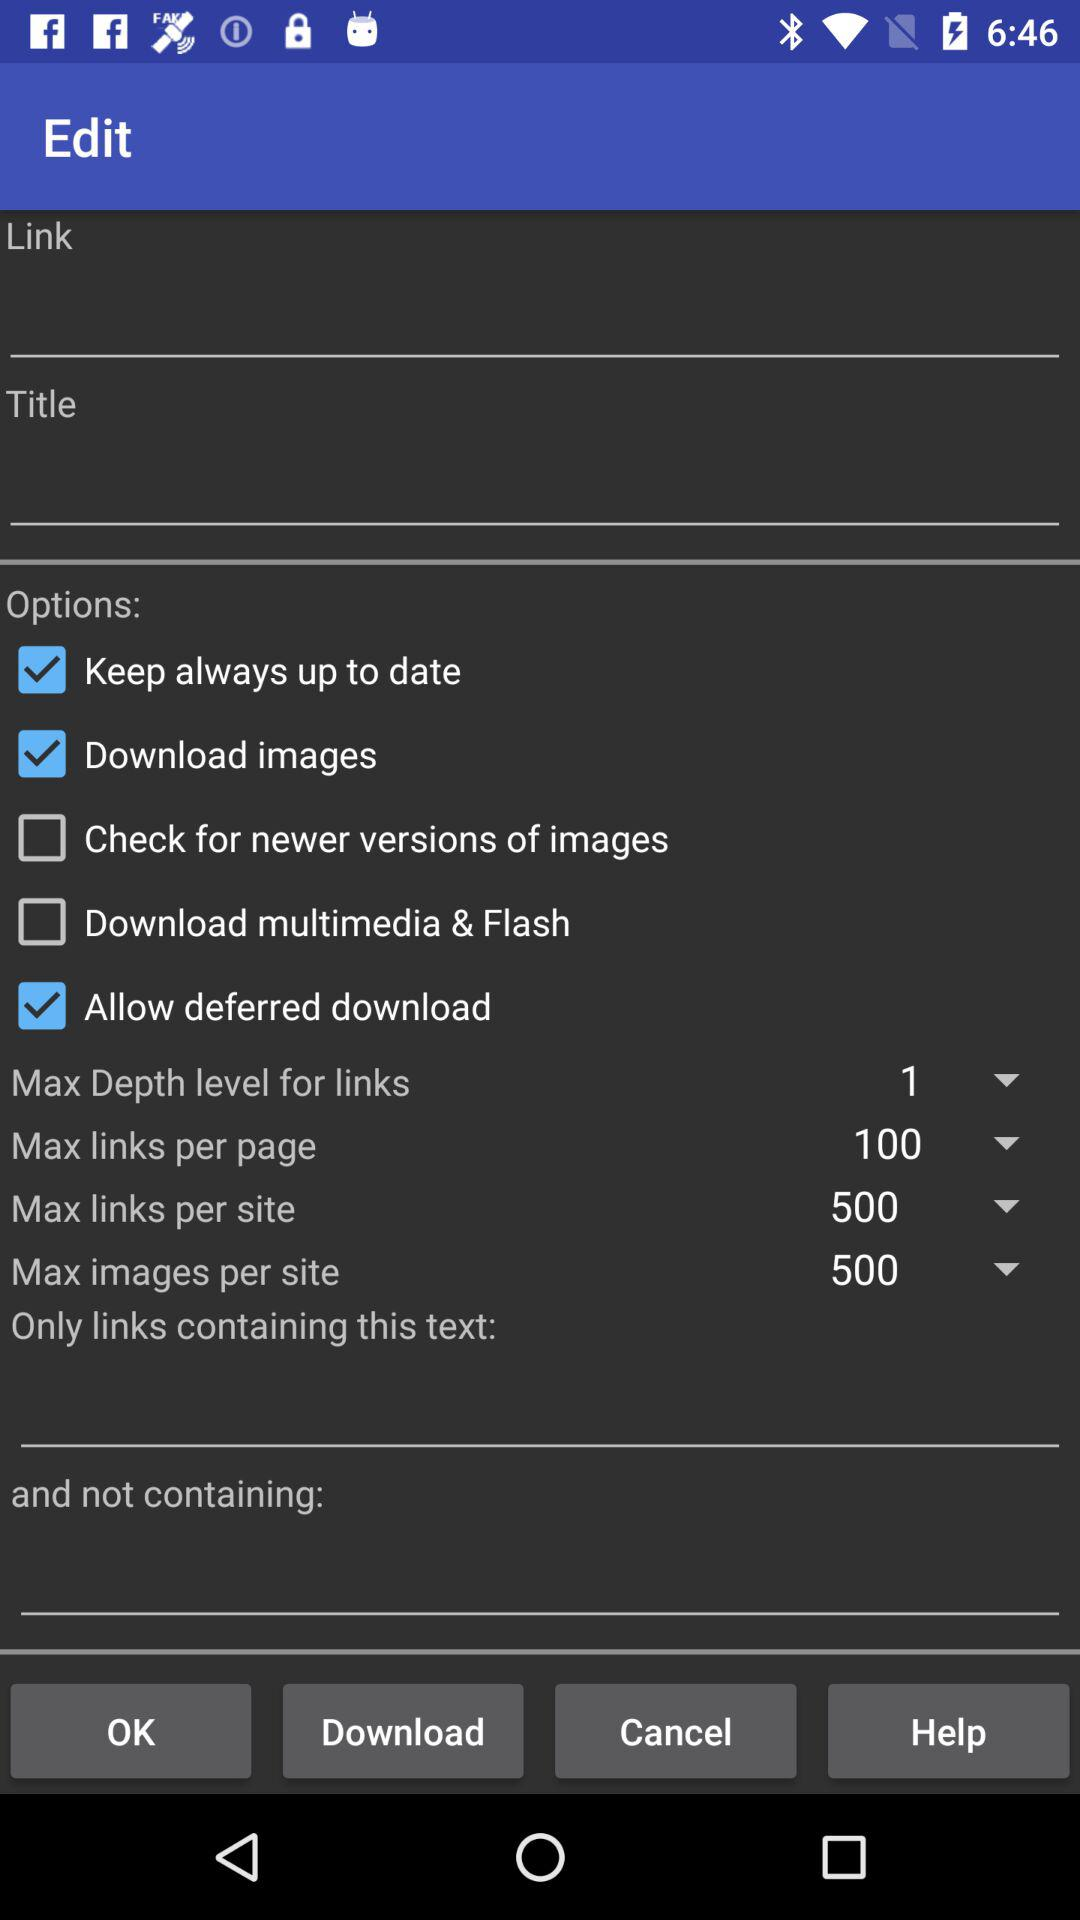What is the status of "Download images"? The status is "on". 